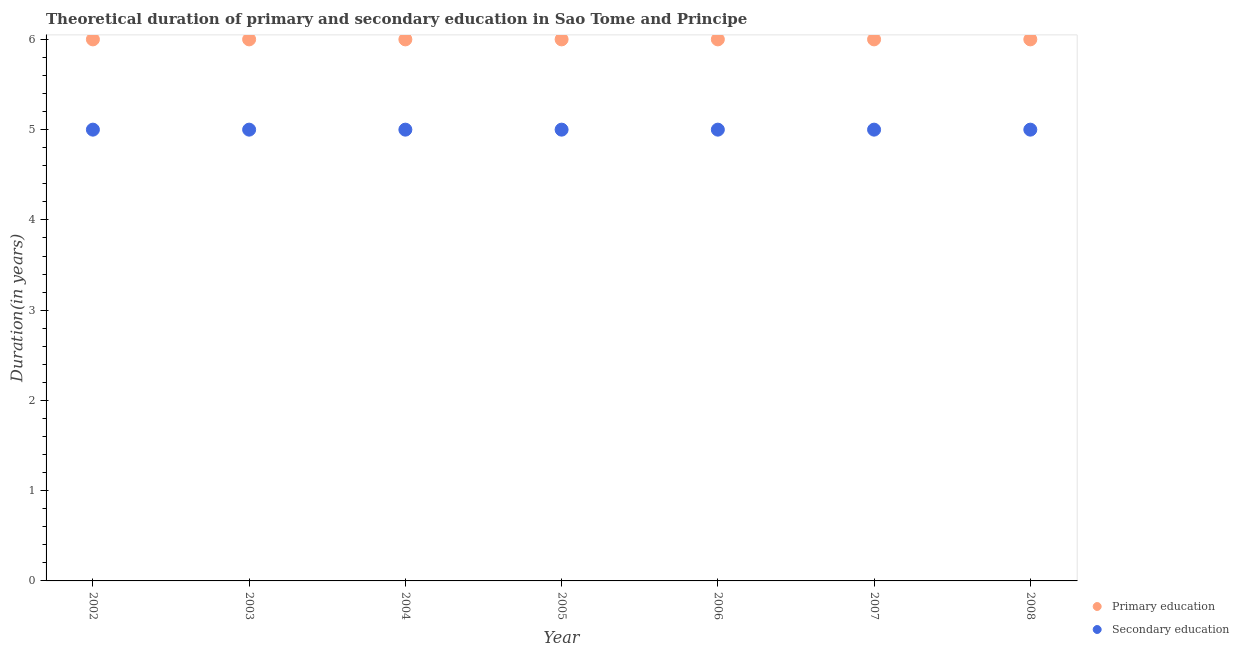How many different coloured dotlines are there?
Offer a very short reply. 2. Is the number of dotlines equal to the number of legend labels?
Make the answer very short. Yes. Across all years, what is the maximum duration of secondary education?
Your answer should be very brief. 5. Across all years, what is the minimum duration of secondary education?
Give a very brief answer. 5. In which year was the duration of secondary education maximum?
Your answer should be compact. 2002. In which year was the duration of primary education minimum?
Offer a very short reply. 2002. What is the total duration of primary education in the graph?
Give a very brief answer. 42. What is the difference between the duration of secondary education in 2007 and that in 2008?
Offer a very short reply. 0. What is the difference between the duration of secondary education in 2007 and the duration of primary education in 2005?
Your answer should be compact. -1. What is the average duration of secondary education per year?
Offer a very short reply. 5. In the year 2005, what is the difference between the duration of secondary education and duration of primary education?
Make the answer very short. -1. What is the ratio of the duration of primary education in 2003 to that in 2006?
Make the answer very short. 1. Is the duration of secondary education in 2002 less than that in 2006?
Make the answer very short. No. In how many years, is the duration of secondary education greater than the average duration of secondary education taken over all years?
Keep it short and to the point. 0. How many dotlines are there?
Provide a succinct answer. 2. How many legend labels are there?
Your response must be concise. 2. How are the legend labels stacked?
Your answer should be compact. Vertical. What is the title of the graph?
Give a very brief answer. Theoretical duration of primary and secondary education in Sao Tome and Principe. What is the label or title of the X-axis?
Provide a short and direct response. Year. What is the label or title of the Y-axis?
Your response must be concise. Duration(in years). What is the Duration(in years) of Secondary education in 2002?
Make the answer very short. 5. What is the Duration(in years) in Primary education in 2003?
Your response must be concise. 6. What is the Duration(in years) of Secondary education in 2004?
Your response must be concise. 5. What is the Duration(in years) in Primary education in 2005?
Offer a very short reply. 6. What is the Duration(in years) in Secondary education in 2005?
Your response must be concise. 5. What is the Duration(in years) of Primary education in 2006?
Keep it short and to the point. 6. What is the Duration(in years) in Secondary education in 2006?
Ensure brevity in your answer.  5. What is the Duration(in years) in Secondary education in 2008?
Keep it short and to the point. 5. Across all years, what is the maximum Duration(in years) in Primary education?
Provide a short and direct response. 6. Across all years, what is the minimum Duration(in years) of Primary education?
Your answer should be very brief. 6. What is the total Duration(in years) in Primary education in the graph?
Offer a terse response. 42. What is the total Duration(in years) of Secondary education in the graph?
Your answer should be very brief. 35. What is the difference between the Duration(in years) of Primary education in 2002 and that in 2003?
Offer a very short reply. 0. What is the difference between the Duration(in years) of Primary education in 2002 and that in 2004?
Provide a short and direct response. 0. What is the difference between the Duration(in years) of Primary education in 2002 and that in 2006?
Provide a short and direct response. 0. What is the difference between the Duration(in years) of Primary education in 2002 and that in 2008?
Your answer should be very brief. 0. What is the difference between the Duration(in years) of Secondary education in 2002 and that in 2008?
Provide a succinct answer. 0. What is the difference between the Duration(in years) of Primary education in 2003 and that in 2004?
Give a very brief answer. 0. What is the difference between the Duration(in years) of Primary education in 2003 and that in 2005?
Offer a terse response. 0. What is the difference between the Duration(in years) of Secondary education in 2003 and that in 2006?
Give a very brief answer. 0. What is the difference between the Duration(in years) of Primary education in 2003 and that in 2007?
Your answer should be very brief. 0. What is the difference between the Duration(in years) of Secondary education in 2004 and that in 2005?
Keep it short and to the point. 0. What is the difference between the Duration(in years) of Primary education in 2004 and that in 2006?
Ensure brevity in your answer.  0. What is the difference between the Duration(in years) of Secondary education in 2004 and that in 2006?
Your answer should be compact. 0. What is the difference between the Duration(in years) in Primary education in 2004 and that in 2007?
Ensure brevity in your answer.  0. What is the difference between the Duration(in years) of Primary education in 2004 and that in 2008?
Provide a succinct answer. 0. What is the difference between the Duration(in years) in Primary education in 2005 and that in 2008?
Give a very brief answer. 0. What is the difference between the Duration(in years) of Secondary education in 2006 and that in 2007?
Provide a succinct answer. 0. What is the difference between the Duration(in years) in Primary education in 2006 and that in 2008?
Give a very brief answer. 0. What is the difference between the Duration(in years) of Primary education in 2007 and that in 2008?
Make the answer very short. 0. What is the difference between the Duration(in years) in Primary education in 2002 and the Duration(in years) in Secondary education in 2003?
Ensure brevity in your answer.  1. What is the difference between the Duration(in years) in Primary education in 2002 and the Duration(in years) in Secondary education in 2004?
Provide a short and direct response. 1. What is the difference between the Duration(in years) in Primary education in 2002 and the Duration(in years) in Secondary education in 2005?
Your answer should be very brief. 1. What is the difference between the Duration(in years) in Primary education in 2002 and the Duration(in years) in Secondary education in 2006?
Provide a short and direct response. 1. What is the difference between the Duration(in years) of Primary education in 2002 and the Duration(in years) of Secondary education in 2007?
Provide a short and direct response. 1. What is the difference between the Duration(in years) in Primary education in 2002 and the Duration(in years) in Secondary education in 2008?
Give a very brief answer. 1. What is the difference between the Duration(in years) of Primary education in 2003 and the Duration(in years) of Secondary education in 2004?
Offer a terse response. 1. What is the difference between the Duration(in years) in Primary education in 2003 and the Duration(in years) in Secondary education in 2005?
Offer a terse response. 1. What is the difference between the Duration(in years) in Primary education in 2004 and the Duration(in years) in Secondary education in 2006?
Your response must be concise. 1. What is the difference between the Duration(in years) of Primary education in 2004 and the Duration(in years) of Secondary education in 2007?
Keep it short and to the point. 1. What is the difference between the Duration(in years) in Primary education in 2004 and the Duration(in years) in Secondary education in 2008?
Ensure brevity in your answer.  1. What is the difference between the Duration(in years) in Primary education in 2005 and the Duration(in years) in Secondary education in 2007?
Your response must be concise. 1. What is the difference between the Duration(in years) of Primary education in 2005 and the Duration(in years) of Secondary education in 2008?
Keep it short and to the point. 1. What is the difference between the Duration(in years) of Primary education in 2007 and the Duration(in years) of Secondary education in 2008?
Offer a terse response. 1. What is the average Duration(in years) in Secondary education per year?
Provide a succinct answer. 5. In the year 2003, what is the difference between the Duration(in years) of Primary education and Duration(in years) of Secondary education?
Give a very brief answer. 1. In the year 2004, what is the difference between the Duration(in years) of Primary education and Duration(in years) of Secondary education?
Offer a very short reply. 1. In the year 2005, what is the difference between the Duration(in years) of Primary education and Duration(in years) of Secondary education?
Provide a short and direct response. 1. In the year 2006, what is the difference between the Duration(in years) of Primary education and Duration(in years) of Secondary education?
Offer a very short reply. 1. In the year 2008, what is the difference between the Duration(in years) in Primary education and Duration(in years) in Secondary education?
Ensure brevity in your answer.  1. What is the ratio of the Duration(in years) of Primary education in 2002 to that in 2003?
Ensure brevity in your answer.  1. What is the ratio of the Duration(in years) of Primary education in 2002 to that in 2004?
Keep it short and to the point. 1. What is the ratio of the Duration(in years) in Secondary education in 2002 to that in 2004?
Your answer should be compact. 1. What is the ratio of the Duration(in years) of Secondary education in 2002 to that in 2005?
Provide a succinct answer. 1. What is the ratio of the Duration(in years) of Primary education in 2002 to that in 2006?
Make the answer very short. 1. What is the ratio of the Duration(in years) in Primary education in 2002 to that in 2007?
Keep it short and to the point. 1. What is the ratio of the Duration(in years) in Secondary education in 2002 to that in 2007?
Ensure brevity in your answer.  1. What is the ratio of the Duration(in years) of Secondary education in 2003 to that in 2005?
Make the answer very short. 1. What is the ratio of the Duration(in years) in Primary education in 2003 to that in 2007?
Provide a succinct answer. 1. What is the ratio of the Duration(in years) in Secondary education in 2003 to that in 2007?
Offer a terse response. 1. What is the ratio of the Duration(in years) in Primary education in 2003 to that in 2008?
Make the answer very short. 1. What is the ratio of the Duration(in years) of Primary education in 2004 to that in 2006?
Offer a very short reply. 1. What is the ratio of the Duration(in years) of Primary education in 2004 to that in 2007?
Your answer should be compact. 1. What is the ratio of the Duration(in years) in Secondary education in 2004 to that in 2007?
Your response must be concise. 1. What is the ratio of the Duration(in years) in Secondary education in 2004 to that in 2008?
Make the answer very short. 1. What is the ratio of the Duration(in years) of Primary education in 2005 to that in 2007?
Offer a terse response. 1. What is the ratio of the Duration(in years) of Secondary education in 2005 to that in 2008?
Ensure brevity in your answer.  1. What is the ratio of the Duration(in years) of Primary education in 2006 to that in 2008?
Your response must be concise. 1. What is the ratio of the Duration(in years) of Secondary education in 2006 to that in 2008?
Provide a succinct answer. 1. What is the ratio of the Duration(in years) of Secondary education in 2007 to that in 2008?
Give a very brief answer. 1. What is the difference between the highest and the second highest Duration(in years) of Secondary education?
Your answer should be very brief. 0. What is the difference between the highest and the lowest Duration(in years) of Primary education?
Make the answer very short. 0. What is the difference between the highest and the lowest Duration(in years) in Secondary education?
Your answer should be compact. 0. 